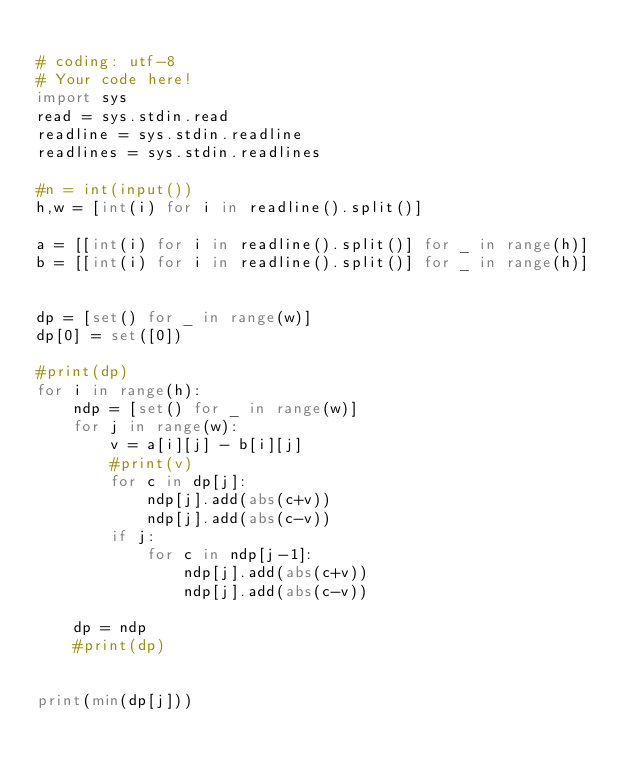Convert code to text. <code><loc_0><loc_0><loc_500><loc_500><_Python_>
# coding: utf-8
# Your code here!
import sys
read = sys.stdin.read
readline = sys.stdin.readline 
readlines = sys.stdin.readlines

#n = int(input())
h,w = [int(i) for i in readline().split()]

a = [[int(i) for i in readline().split()] for _ in range(h)]
b = [[int(i) for i in readline().split()] for _ in range(h)]


dp = [set() for _ in range(w)]
dp[0] = set([0])

#print(dp)
for i in range(h):
    ndp = [set() for _ in range(w)]
    for j in range(w):
        v = a[i][j] - b[i][j]
        #print(v)
        for c in dp[j]:
            ndp[j].add(abs(c+v))
            ndp[j].add(abs(c-v))
        if j:
            for c in ndp[j-1]:
                ndp[j].add(abs(c+v))
                ndp[j].add(abs(c-v))

    dp = ndp
    #print(dp)
    

print(min(dp[j]))












</code> 